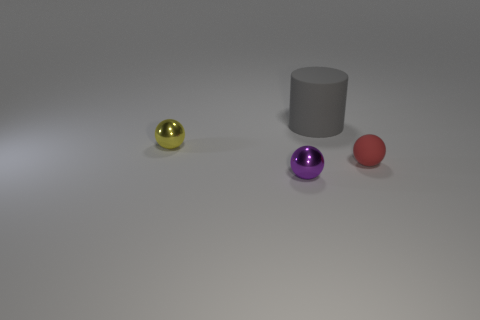What materials do the spheres in the image appear to be made of? The spheres in the image seem to have metallic surfaces, judging by the way light reflects off of them. The yellow sphere, in particular, appears to have a highly reflective, perhaps polished, metallic finish. 